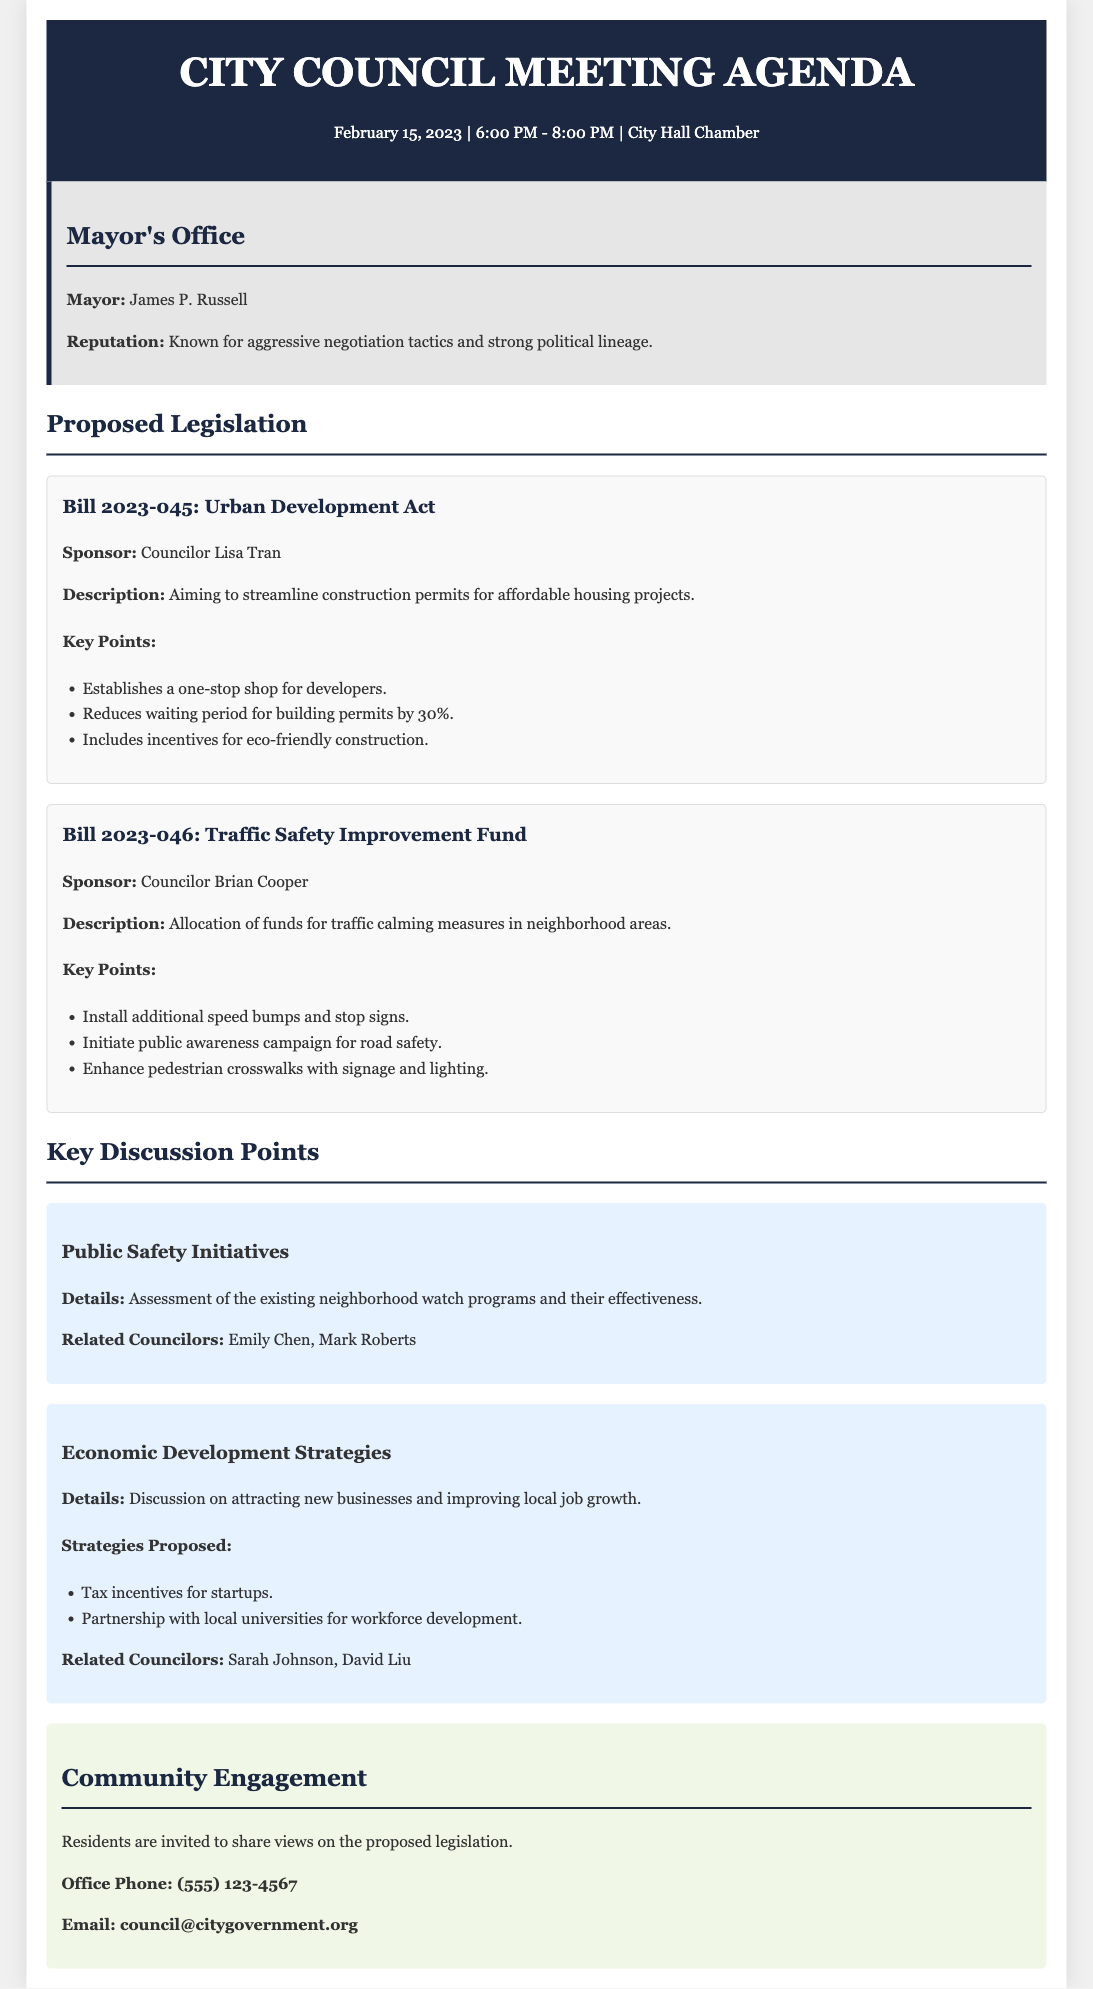What is the date of the City Council Meeting? The date of the City Council Meeting is explicitly stated in the agenda document as February 15, 2023.
Answer: February 15, 2023 Who is the sponsor of Bill 2023-045? The sponsor information for each proposed legislation is mentioned in the document, leading to the name of the sponsor for Bill 2023-045.
Answer: Councilor Lisa Tran What is the main goal of the Urban Development Act? The description section of Bill 2023-045 identifies its aim, specifically in relation to affordable housing projects.
Answer: Streamline construction permits for affordable housing projects How much does the Traffic Safety Improvement Fund allocate for traffic calming measures? The allocation details are outlined in the description of Bill 2023-046, which discusses funds specifically for neighborhood areas.
Answer: Funds for traffic calming measures Which councilor is related to public safety initiatives? The key discussion points section lists related councilors for each discussion point, confirming involvement in public safety initiatives.
Answer: Emily Chen What strategies are proposed in the Economic Development Strategies discussion? The key discussion point about economic development includes proposed strategies that are explicitly listed, focusing on attracting new businesses.
Answer: Tax incentives for startups What time does the City Council Meeting start? The starting time for the meeting is provided in the header section of the agenda document.
Answer: 6:00 PM How can residents share their views on the legislation? There are specified contact details provided for community engagement in the document, highlighting ways residents can communicate.
Answer: Contact the office via phone or email 